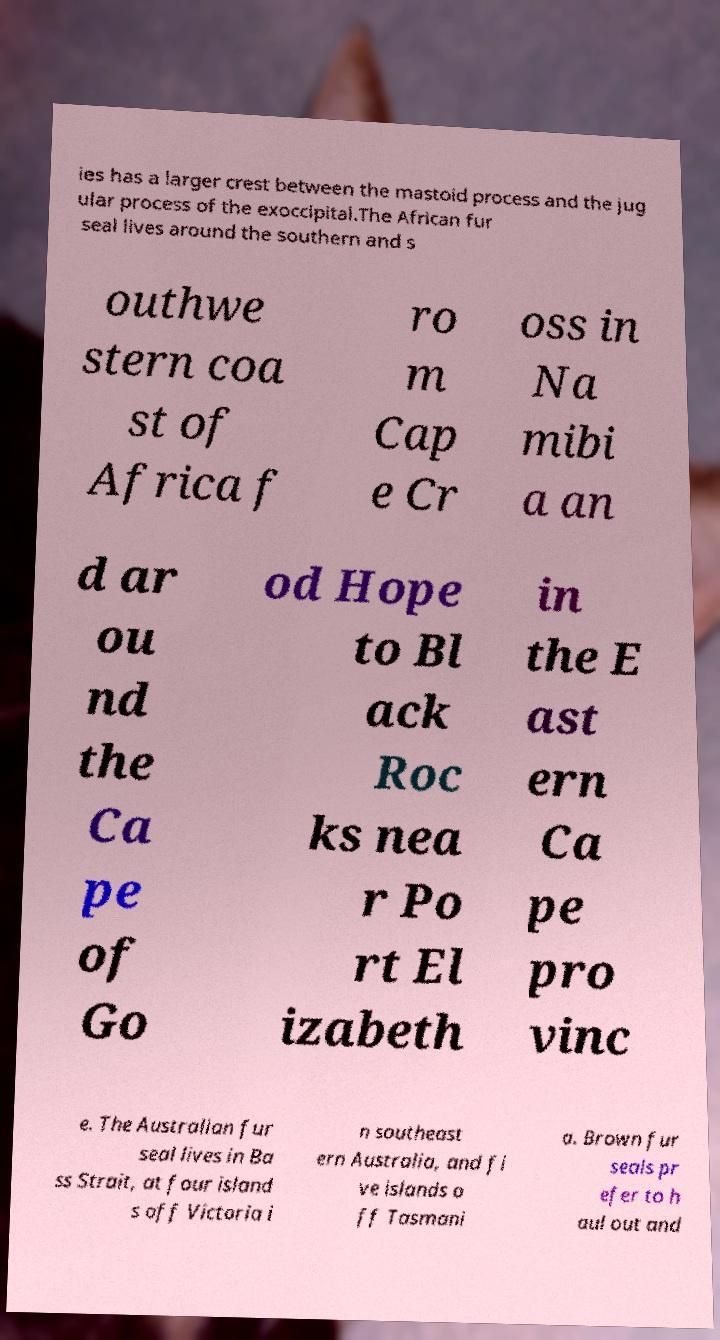Could you assist in decoding the text presented in this image and type it out clearly? ies has a larger crest between the mastoid process and the jug ular process of the exoccipital.The African fur seal lives around the southern and s outhwe stern coa st of Africa f ro m Cap e Cr oss in Na mibi a an d ar ou nd the Ca pe of Go od Hope to Bl ack Roc ks nea r Po rt El izabeth in the E ast ern Ca pe pro vinc e. The Australian fur seal lives in Ba ss Strait, at four island s off Victoria i n southeast ern Australia, and fi ve islands o ff Tasmani a. Brown fur seals pr efer to h aul out and 